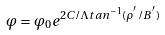<formula> <loc_0><loc_0><loc_500><loc_500>\varphi = \varphi _ { 0 } e ^ { 2 C / \Lambda t a n ^ { - 1 } ( \rho ^ { ^ { \prime } } / B ^ { ^ { \prime } } ) }</formula> 